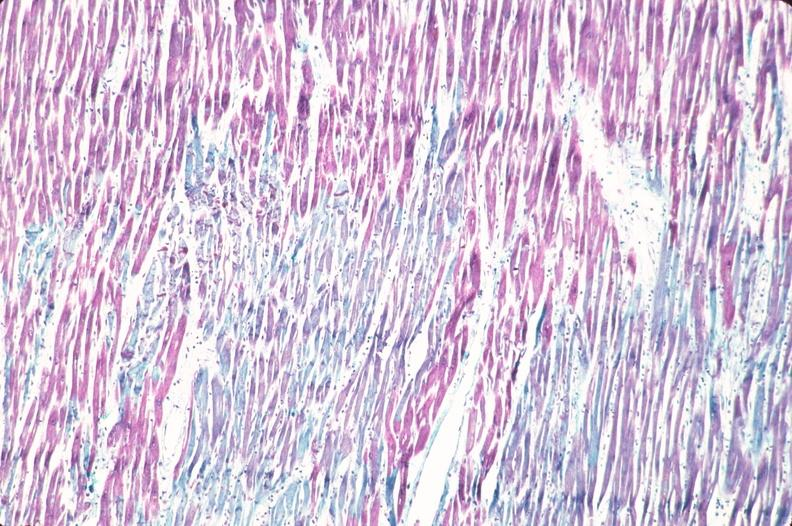s cardiovascular present?
Answer the question using a single word or phrase. Yes 